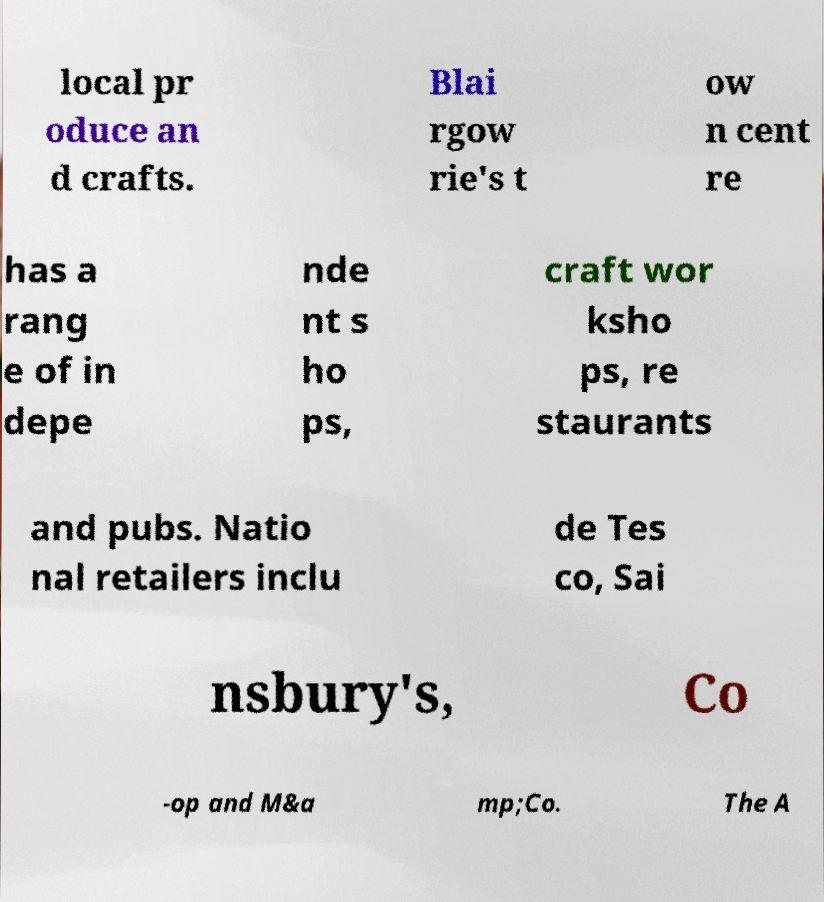Can you accurately transcribe the text from the provided image for me? local pr oduce an d crafts. Blai rgow rie's t ow n cent re has a rang e of in depe nde nt s ho ps, craft wor ksho ps, re staurants and pubs. Natio nal retailers inclu de Tes co, Sai nsbury's, Co -op and M&a mp;Co. The A 